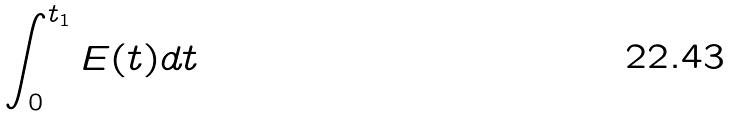Convert formula to latex. <formula><loc_0><loc_0><loc_500><loc_500>\int _ { 0 } ^ { t _ { 1 } } E ( t ) d t</formula> 